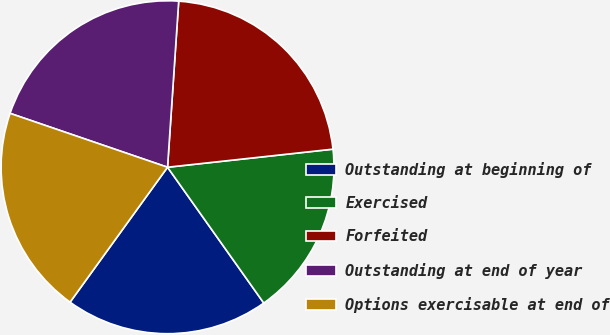Convert chart to OTSL. <chart><loc_0><loc_0><loc_500><loc_500><pie_chart><fcel>Outstanding at beginning of<fcel>Exercised<fcel>Forfeited<fcel>Outstanding at end of year<fcel>Options exercisable at end of<nl><fcel>19.77%<fcel>16.92%<fcel>22.2%<fcel>20.82%<fcel>20.29%<nl></chart> 